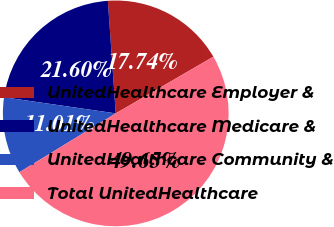Convert chart to OTSL. <chart><loc_0><loc_0><loc_500><loc_500><pie_chart><fcel>UnitedHealthcare Employer &<fcel>UnitedHealthcare Medicare &<fcel>UnitedHealthcare Community &<fcel>Total UnitedHealthcare<nl><fcel>17.74%<fcel>21.6%<fcel>11.01%<fcel>49.65%<nl></chart> 